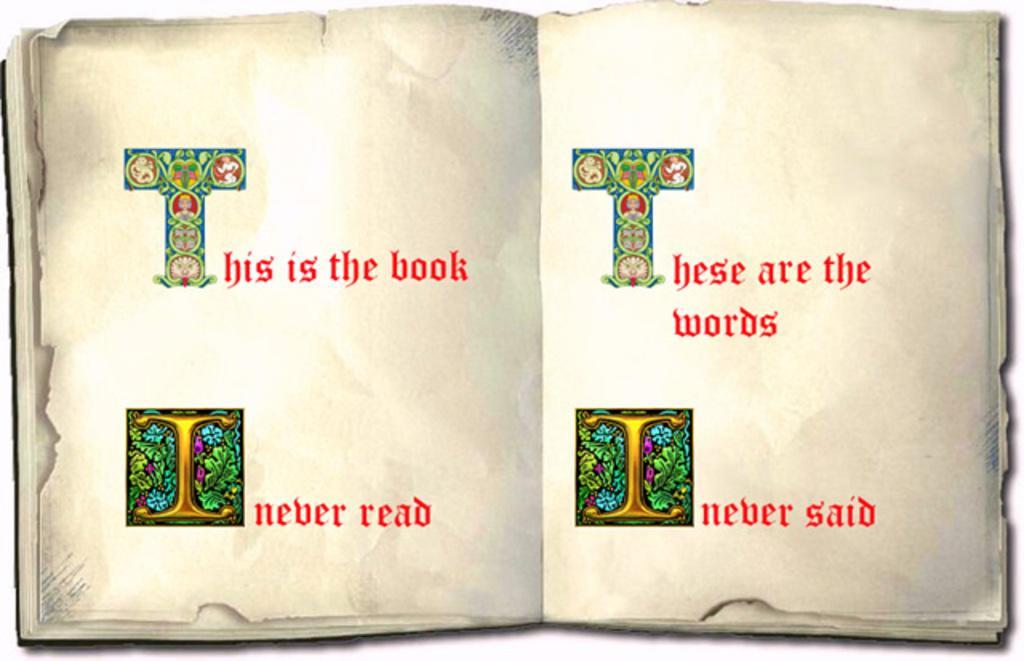Describe this image in one or two sentences. In the image we can see there is an open book and on page it's written "This is the book", "These are the words". On the two sided pages letter T and I are decorated. 